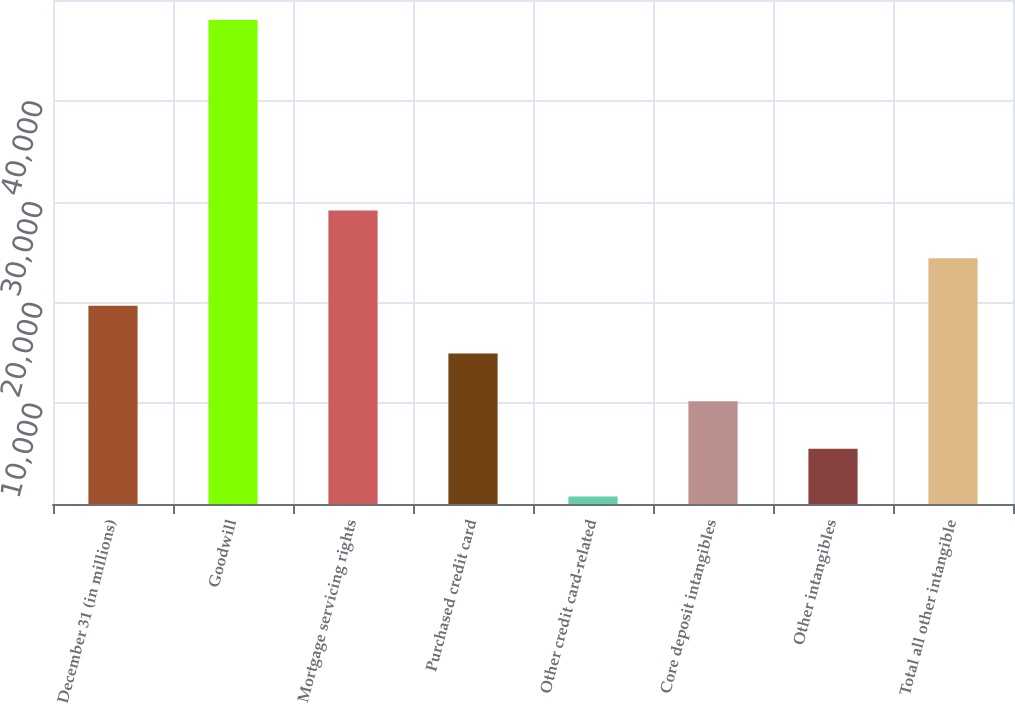Convert chart to OTSL. <chart><loc_0><loc_0><loc_500><loc_500><bar_chart><fcel>December 31 (in millions)<fcel>Goodwill<fcel>Mortgage servicing rights<fcel>Purchased credit card<fcel>Other credit card-related<fcel>Core deposit intangibles<fcel>Other intangibles<fcel>Total all other intangible<nl><fcel>19656.6<fcel>48027<fcel>29113.4<fcel>14928.2<fcel>743<fcel>10199.8<fcel>5471.4<fcel>24385<nl></chart> 